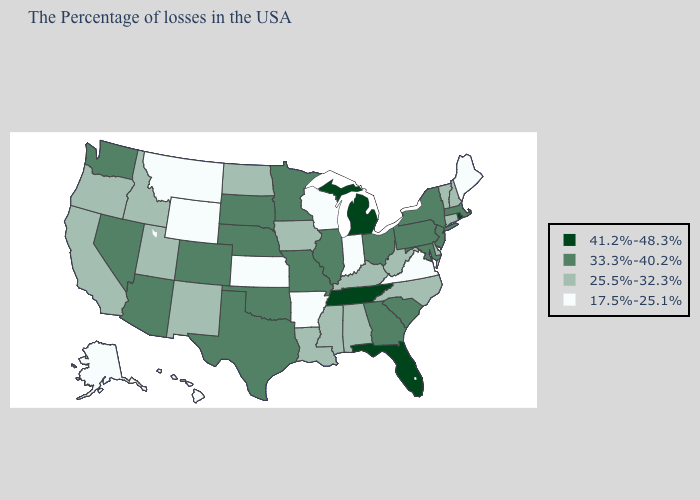Which states have the lowest value in the USA?
Write a very short answer. Maine, Virginia, Indiana, Wisconsin, Arkansas, Kansas, Wyoming, Montana, Alaska, Hawaii. Does North Dakota have the lowest value in the USA?
Quick response, please. No. What is the value of Pennsylvania?
Quick response, please. 33.3%-40.2%. Does Colorado have the lowest value in the USA?
Quick response, please. No. What is the value of Nebraska?
Keep it brief. 33.3%-40.2%. Which states have the highest value in the USA?
Write a very short answer. Rhode Island, Florida, Michigan, Tennessee. Does Texas have a higher value than Maryland?
Concise answer only. No. What is the value of Illinois?
Quick response, please. 33.3%-40.2%. Does the first symbol in the legend represent the smallest category?
Write a very short answer. No. Name the states that have a value in the range 41.2%-48.3%?
Be succinct. Rhode Island, Florida, Michigan, Tennessee. What is the lowest value in the USA?
Short answer required. 17.5%-25.1%. How many symbols are there in the legend?
Answer briefly. 4. Does Tennessee have the highest value in the USA?
Be succinct. Yes. Among the states that border Mississippi , does Tennessee have the lowest value?
Answer briefly. No. 